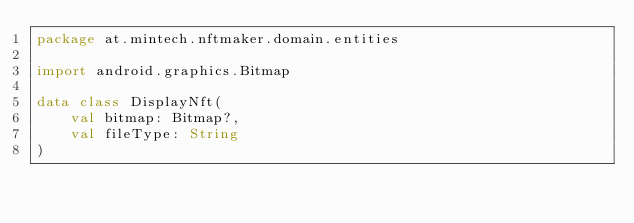Convert code to text. <code><loc_0><loc_0><loc_500><loc_500><_Kotlin_>package at.mintech.nftmaker.domain.entities

import android.graphics.Bitmap

data class DisplayNft(
    val bitmap: Bitmap?,
    val fileType: String
)
</code> 